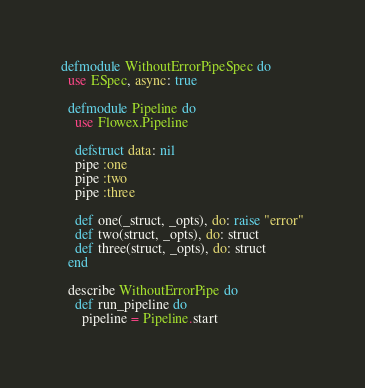<code> <loc_0><loc_0><loc_500><loc_500><_Elixir_>defmodule WithoutErrorPipeSpec do
  use ESpec, async: true

  defmodule Pipeline do
    use Flowex.Pipeline

    defstruct data: nil
    pipe :one
    pipe :two
    pipe :three

    def one(_struct, _opts), do: raise "error"
    def two(struct, _opts), do: struct
    def three(struct, _opts), do: struct
  end

  describe WithoutErrorPipe do
    def run_pipeline do
      pipeline = Pipeline.start</code> 